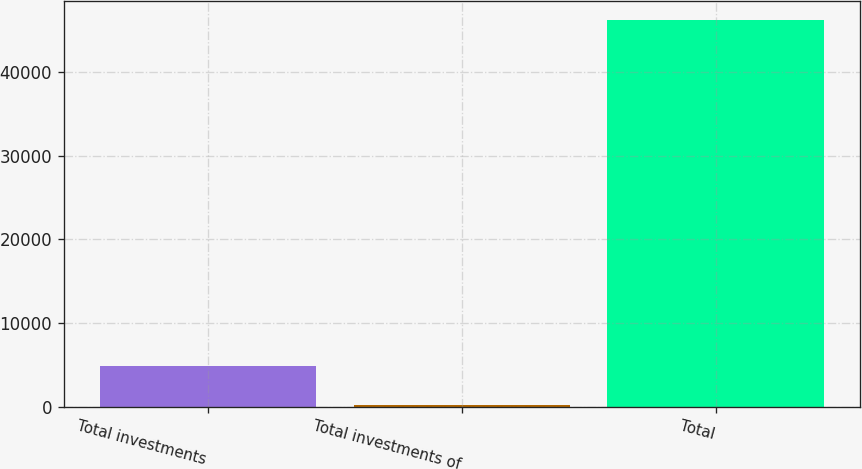Convert chart. <chart><loc_0><loc_0><loc_500><loc_500><bar_chart><fcel>Total investments<fcel>Total investments of<fcel>Total<nl><fcel>4832.6<fcel>246<fcel>46112<nl></chart> 